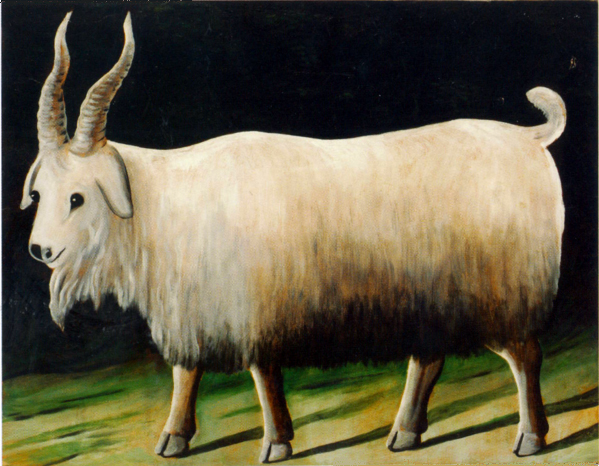Can you describe the main features of this image for me? The image features an elegant white goat, depicted with shaggy fur and gracefully curved horns, set against a contrasting dark background. The goat's tranquil expression and the gentle gradients of white to gray in its coat suggest a serene mood, while the strong lighting highlights its figure effectively, enhancing the visual impact of the animal. The carefully painted shadows and the green field under the goat's hooves add depth and realism to the portrait, positioning this piece firmly within the animal portraiture genre. Additionally, the artist's use of bold outlines and the slightly abstract style of the background suggest a modern twist on traditional animal studies. 